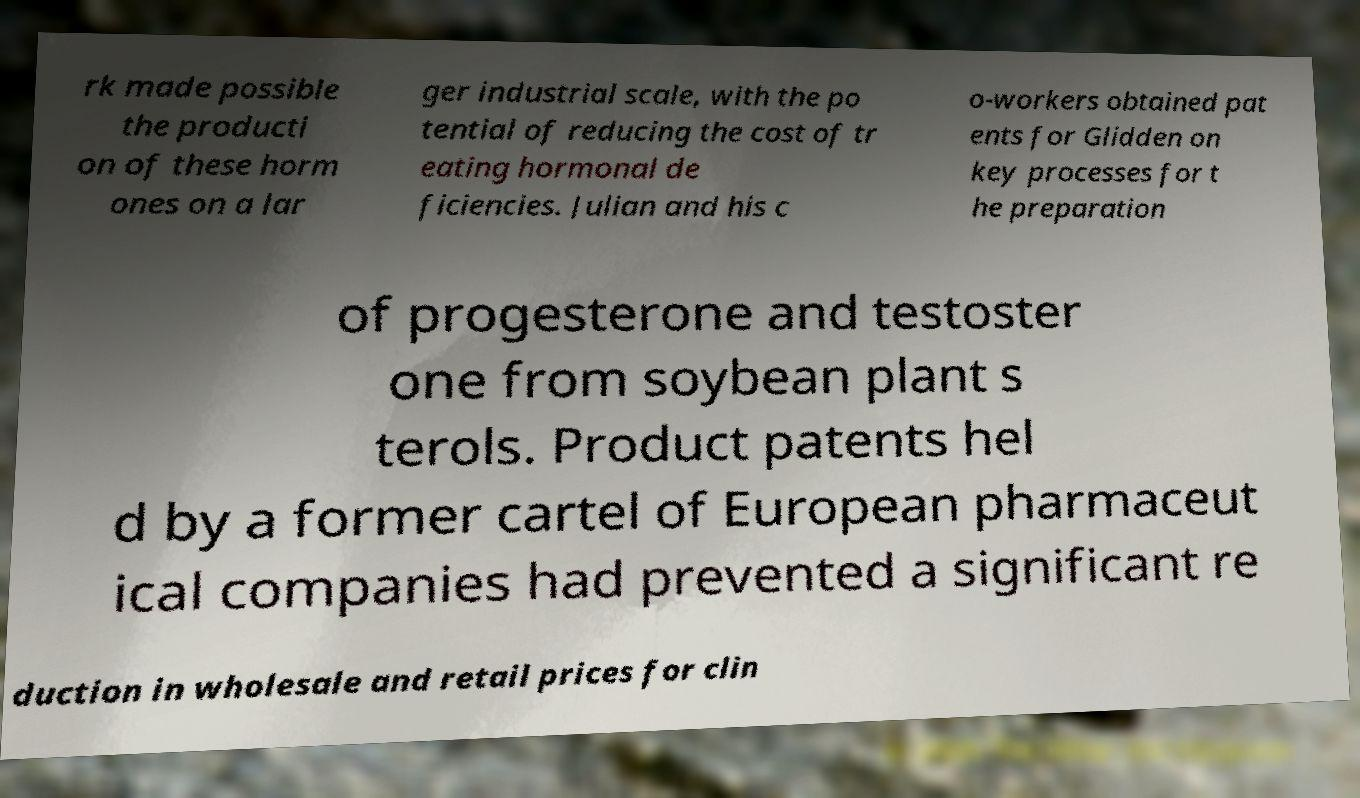There's text embedded in this image that I need extracted. Can you transcribe it verbatim? rk made possible the producti on of these horm ones on a lar ger industrial scale, with the po tential of reducing the cost of tr eating hormonal de ficiencies. Julian and his c o-workers obtained pat ents for Glidden on key processes for t he preparation of progesterone and testoster one from soybean plant s terols. Product patents hel d by a former cartel of European pharmaceut ical companies had prevented a significant re duction in wholesale and retail prices for clin 